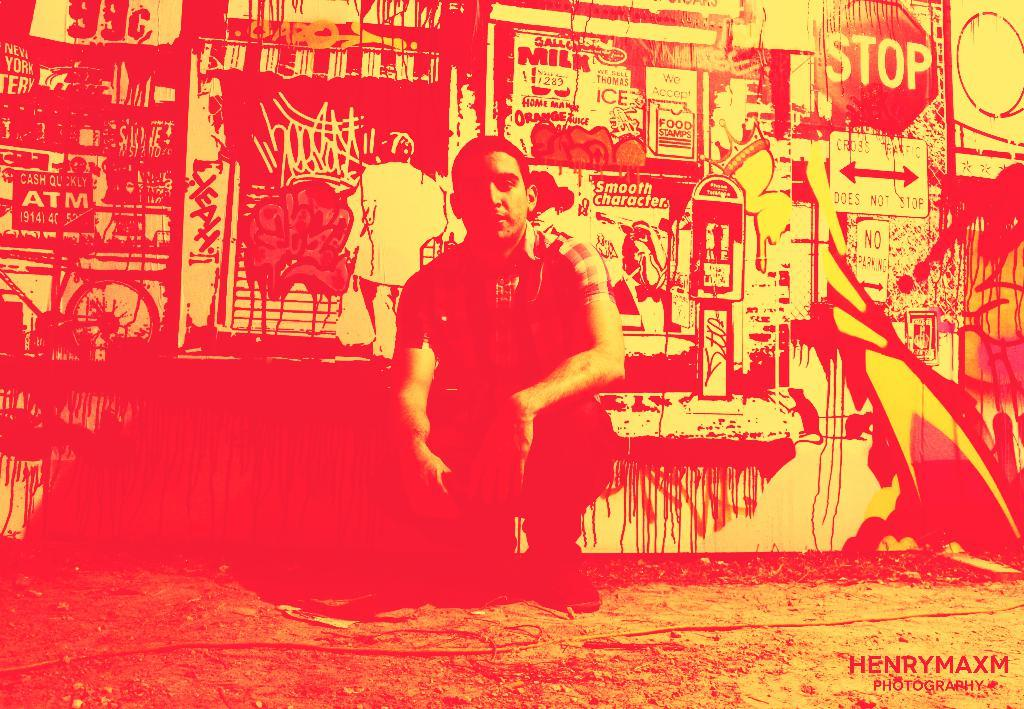<image>
Provide a brief description of the given image. A man sits in front of a wall covered in signs, including a stop sign and a 99 cent sign. 